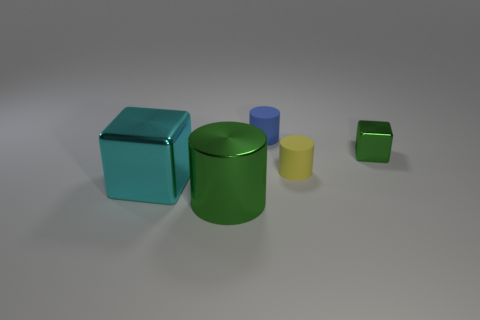Add 1 yellow objects. How many objects exist? 6 Subtract all cylinders. How many objects are left? 2 Subtract all blue matte cylinders. Subtract all green shiny things. How many objects are left? 2 Add 3 large shiny cubes. How many large shiny cubes are left? 4 Add 4 blue matte spheres. How many blue matte spheres exist? 4 Subtract 1 green cylinders. How many objects are left? 4 